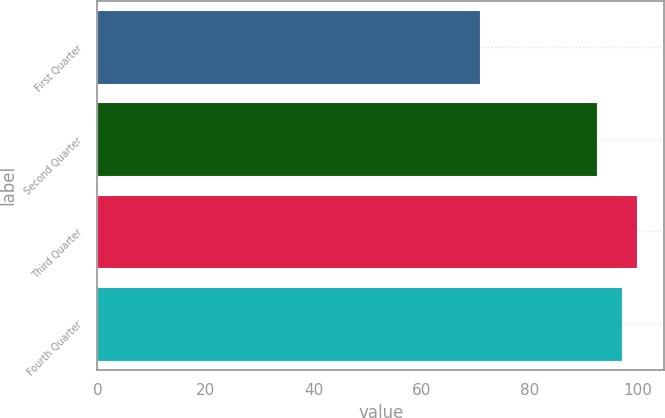<chart> <loc_0><loc_0><loc_500><loc_500><bar_chart><fcel>First Quarter<fcel>Second Quarter<fcel>Third Quarter<fcel>Fourth Quarter<nl><fcel>70.75<fcel>92.39<fcel>99.9<fcel>97.11<nl></chart> 